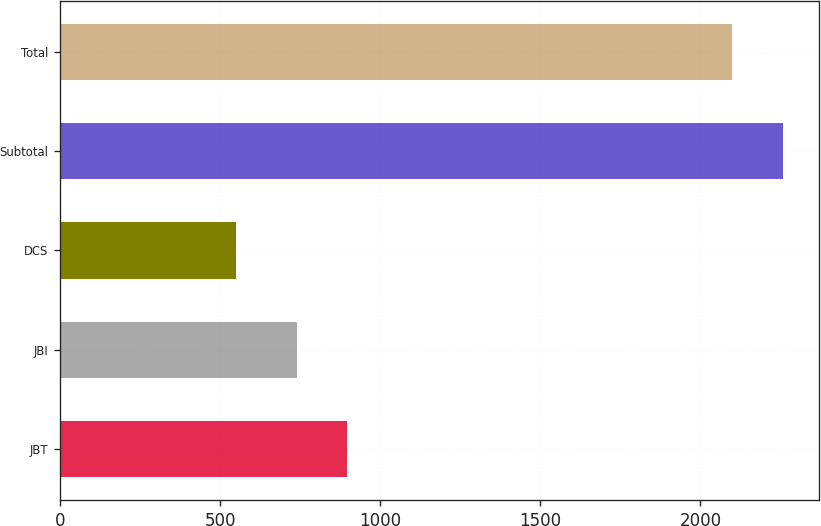<chart> <loc_0><loc_0><loc_500><loc_500><bar_chart><fcel>JBT<fcel>JBI<fcel>DCS<fcel>Subtotal<fcel>Total<nl><fcel>897.47<fcel>740.5<fcel>548.7<fcel>2257.27<fcel>2100.3<nl></chart> 